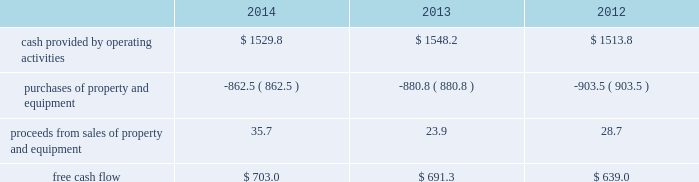Financial assurance we must provide financial assurance to governmental agencies and a variety of other entities under applicable environmental regulations relating to our landfill operations for capping , closure and post-closure costs , and related to our performance under certain collection , landfill and transfer station contracts .
We satisfy these financial assurance requirements by providing surety bonds , letters of credit , or insurance policies ( financial assurance instruments ) , or trust deposits , which are included in restricted cash and marketable securities and other assets in our consolidated balance sheets .
The amount of the financial assurance requirements for capping , closure and post-closure costs is determined by applicable state environmental regulations .
The financial assurance requirements for capping , closure and post-closure costs may be associated with a portion of the landfill or the entire landfill .
Generally , states require a third-party engineering specialist to determine the estimated capping , closure and post-closure costs that are used to determine the required amount of financial assurance for a landfill .
The amount of financial assurance required can , and generally will , differ from the obligation determined and recorded under u.s .
Gaap .
The amount of the financial assurance requirements related to contract performance varies by contract .
Additionally , we must provide financial assurance for our insurance program and collateral for certain performance obligations .
We do not expect a material increase in financial assurance requirements during 2015 , although the mix of financial assurance instruments may change .
These financial assurance instruments are issued in the normal course of business and are not considered indebtedness .
Because we currently have no liability for the financial assurance instruments , they are not reflected in our consolidated balance sheets ; however , we record capping , closure and post-closure liabilities and insurance liabilities as they are incurred .
The underlying obligations of the financial assurance instruments , in excess of those already reflected in our consolidated balance sheets , would be recorded if it is probable that we would be unable to fulfill our related obligations .
We do not expect this to occur .
Off-balance sheet arrangements we have no off-balance sheet debt or similar obligations , other than operating leases and financial assurances , which are not classified as debt .
We have no transactions or obligations with related parties that are not disclosed , consolidated into or reflected in our reported financial position or results of operations .
We have not guaranteed any third-party debt .
Free cash flow we define free cash flow , which is not a measure determined in accordance with u.s .
Gaap , as cash provided by operating activities less purchases of property and equipment , plus proceeds from sales of property and equipment , as presented in our consolidated statements of cash flows .
The table calculates our free cash flow for the years ended december 31 , 2014 , 2013 and 2012 ( in millions of dollars ) : .
For a discussion of the changes in the components of free cash flow , you should read our discussion regarding cash flows provided by operating activities and cash flows used in investing activities contained elsewhere in this management 2019s discussion and analysis of financial condition and results of operations. .
In 2013 what was the percentage decline in free cash flow? 
Computations: (691.3 - 1548.2)
Answer: -856.9. 